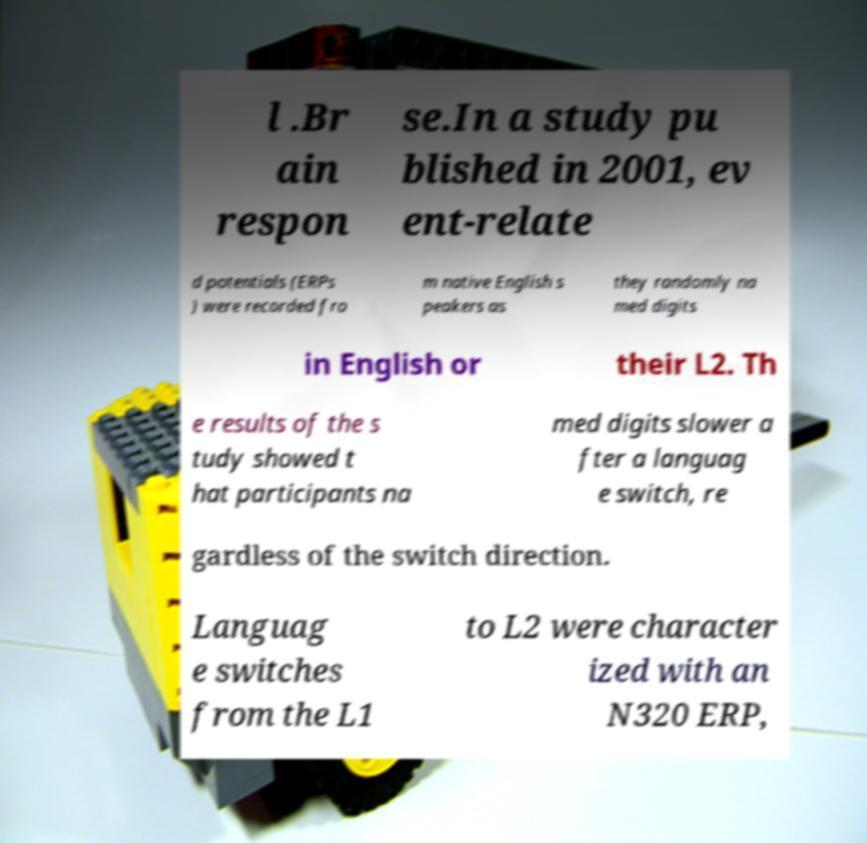Please identify and transcribe the text found in this image. l .Br ain respon se.In a study pu blished in 2001, ev ent-relate d potentials (ERPs ) were recorded fro m native English s peakers as they randomly na med digits in English or their L2. Th e results of the s tudy showed t hat participants na med digits slower a fter a languag e switch, re gardless of the switch direction. Languag e switches from the L1 to L2 were character ized with an N320 ERP, 